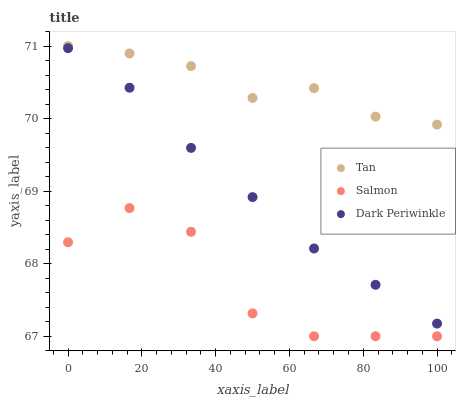Does Salmon have the minimum area under the curve?
Answer yes or no. Yes. Does Tan have the maximum area under the curve?
Answer yes or no. Yes. Does Dark Periwinkle have the minimum area under the curve?
Answer yes or no. No. Does Dark Periwinkle have the maximum area under the curve?
Answer yes or no. No. Is Dark Periwinkle the smoothest?
Answer yes or no. Yes. Is Salmon the roughest?
Answer yes or no. Yes. Is Salmon the smoothest?
Answer yes or no. No. Is Dark Periwinkle the roughest?
Answer yes or no. No. Does Salmon have the lowest value?
Answer yes or no. Yes. Does Dark Periwinkle have the lowest value?
Answer yes or no. No. Does Tan have the highest value?
Answer yes or no. Yes. Does Dark Periwinkle have the highest value?
Answer yes or no. No. Is Salmon less than Dark Periwinkle?
Answer yes or no. Yes. Is Tan greater than Dark Periwinkle?
Answer yes or no. Yes. Does Salmon intersect Dark Periwinkle?
Answer yes or no. No. 